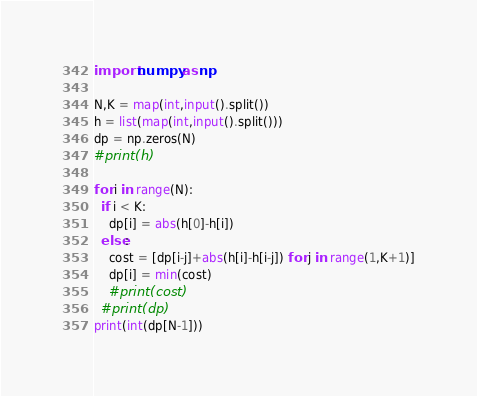<code> <loc_0><loc_0><loc_500><loc_500><_Python_>import numpy as np

N,K = map(int,input().split())
h = list(map(int,input().split()))
dp = np.zeros(N)
#print(h)
  
for i in range(N):
  if i < K:
    dp[i] = abs(h[0]-h[i])
  else:  
    cost = [dp[i-j]+abs(h[i]-h[i-j]) for j in range(1,K+1)]
    dp[i] = min(cost)
    #print(cost)
  #print(dp)
print(int(dp[N-1]))</code> 